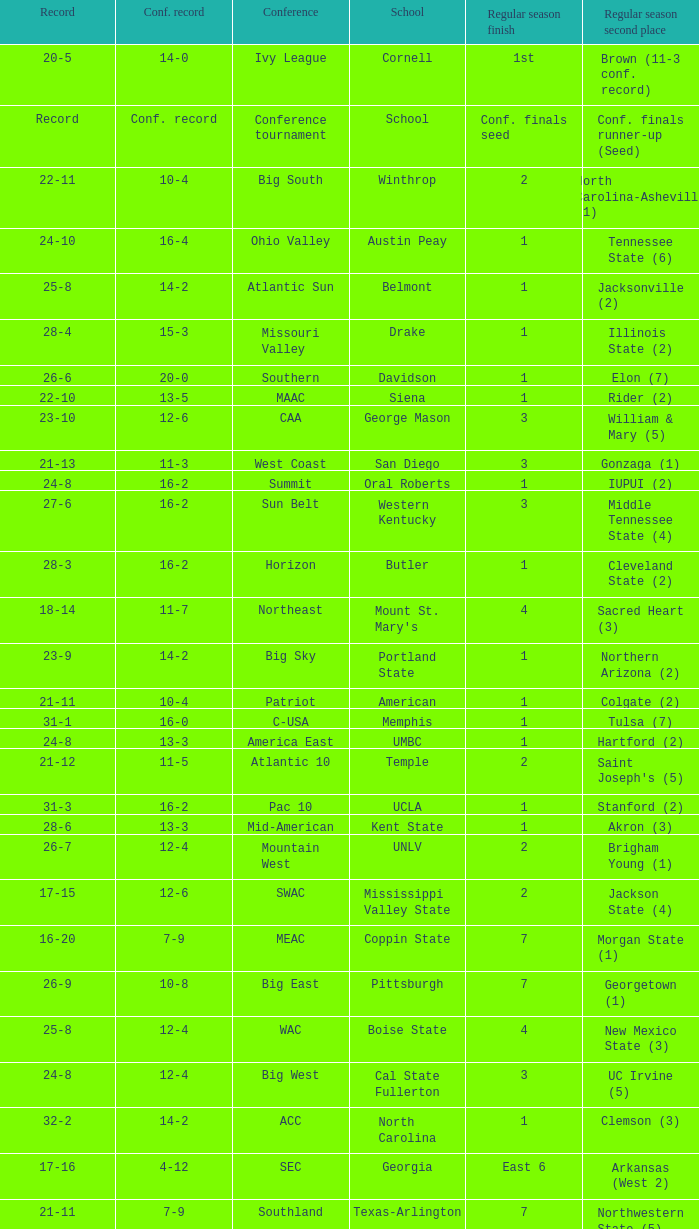Which conference is Belmont in? Atlantic Sun. 